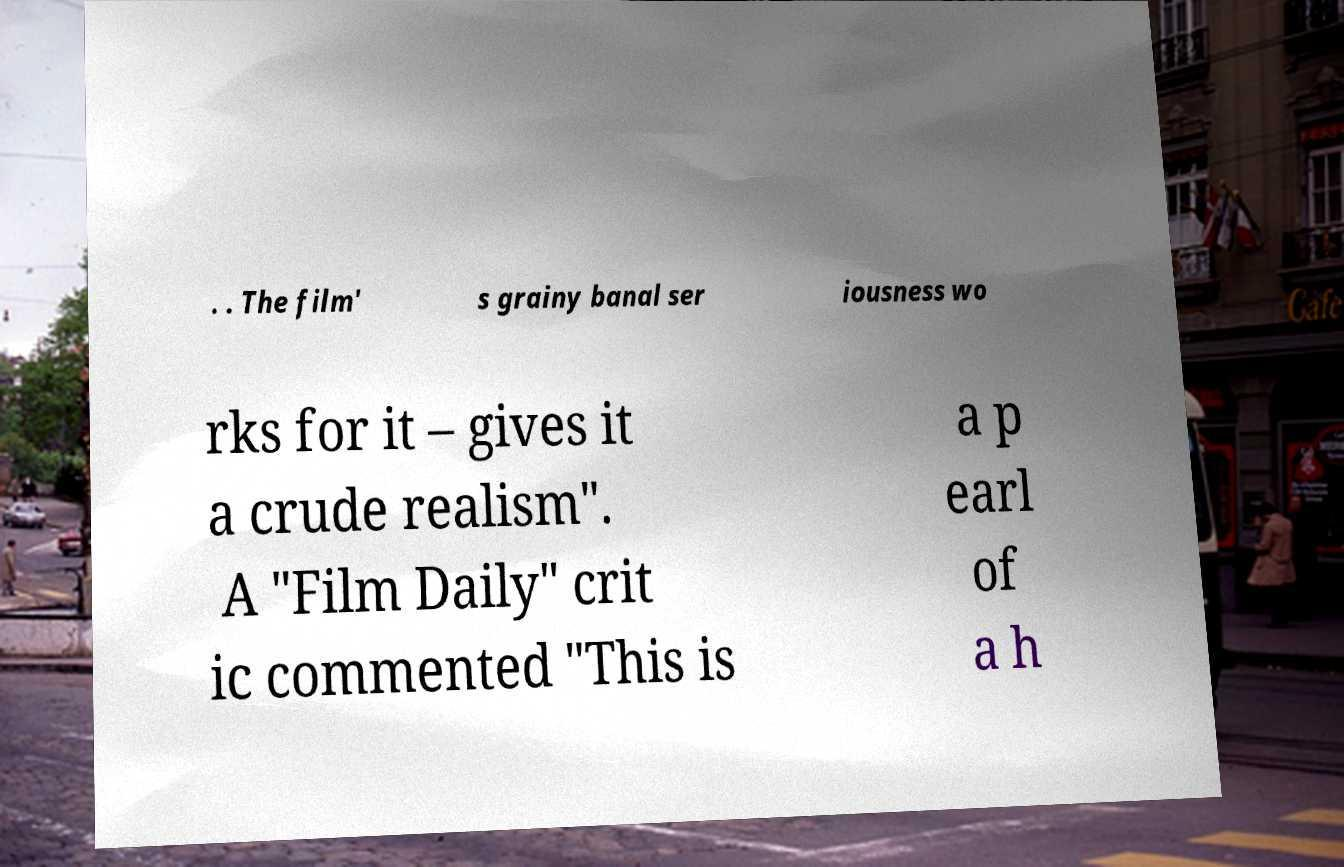For documentation purposes, I need the text within this image transcribed. Could you provide that? . . The film' s grainy banal ser iousness wo rks for it – gives it a crude realism". A "Film Daily" crit ic commented "This is a p earl of a h 